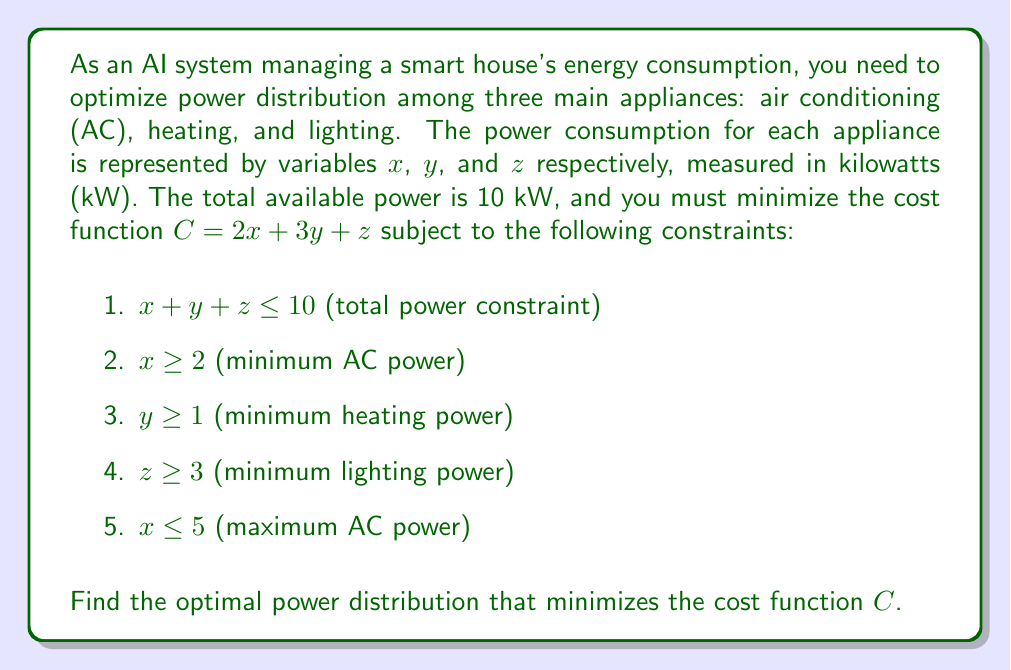Show me your answer to this math problem. To solve this linear programming problem, we'll use the simplex method:

1. Convert inequality constraints to equations by introducing slack variables:
   $$x + y + z + s_1 = 10$$
   $$x - s_2 = 2$$
   $$y - s_3 = 1$$
   $$z - s_4 = 3$$
   $$x + s_5 = 5$$

2. Set up the initial tableau:
   $$\begin{array}{c|cccccccc|c}
   & x & y & z & s_1 & s_2 & s_3 & s_4 & s_5 & RHS \\
   \hline
   -C & -2 & -3 & -1 & 0 & 0 & 0 & 0 & 0 & 0 \\
   s_1 & 1 & 1 & 1 & 1 & 0 & 0 & 0 & 0 & 10 \\
   x & 1 & 0 & 0 & 0 & -1 & 0 & 0 & 1 & 2 \\
   y & 0 & 1 & 0 & 0 & 0 & -1 & 0 & 0 & 1 \\
   z & 0 & 0 & 1 & 0 & 0 & 0 & -1 & 0 & 3 \\
   \end{array}$$

3. Identify the pivot column (most negative in objective row): $y$ (-3)

4. Calculate ratios and identify pivot row:
   $s_1: 10/1 = 10$
   $y: 1/1 = 1$ (pivot row)
   $z: 3/0 = \infty$

5. Perform row operations to get:
   $$\begin{array}{c|cccccccc|c}
   & x & y & z & s_1 & s_2 & s_3 & s_4 & s_5 & RHS \\
   \hline
   -C & -2 & 0 & -1 & 0 & 0 & 3 & 0 & 0 & 3 \\
   s_1 & 1 & 0 & 1 & 1 & 0 & 1 & 0 & 0 & 9 \\
   x & 1 & 0 & 0 & 0 & -1 & 0 & 0 & 1 & 2 \\
   y & 0 & 1 & 0 & 0 & 0 & -1 & 0 & 0 & 1 \\
   z & 0 & 0 & 1 & 0 & 0 & 0 & -1 & 0 & 3 \\
   \end{array}$$

6. Repeat steps 3-5 until no negative values remain in the objective row.

7. Final tableau:
   $$\begin{array}{c|cccccccc|c}
   & x & y & z & s_1 & s_2 & s_3 & s_4 & s_5 & RHS \\
   \hline
   -C & 0 & 0 & 0 & 0 & 2 & 3 & 1 & 0 & 13 \\
   s_1 & 0 & 0 & 0 & 1 & 1 & 1 & 1 & -1 & 4 \\
   x & 1 & 0 & 0 & 0 & -1 & 0 & 0 & 1 & 2 \\
   y & 0 & 1 & 0 & 0 & 0 & -1 & 0 & 0 & 1 \\
   z & 0 & 0 & 1 & 0 & 0 & 0 & -1 & 0 & 3 \\
   \end{array}$$

8. Read the optimal solution:
   $x = 2, y = 1, z = 3$

9. Calculate the minimum cost:
   $C = 2(2) + 3(1) + 1(3) = 4 + 3 + 3 = 10$
Answer: The optimal power distribution is:
Air conditioning (x): 2 kW
Heating (y): 1 kW
Lighting (z): 3 kW

The minimum cost is $C = 10$. 